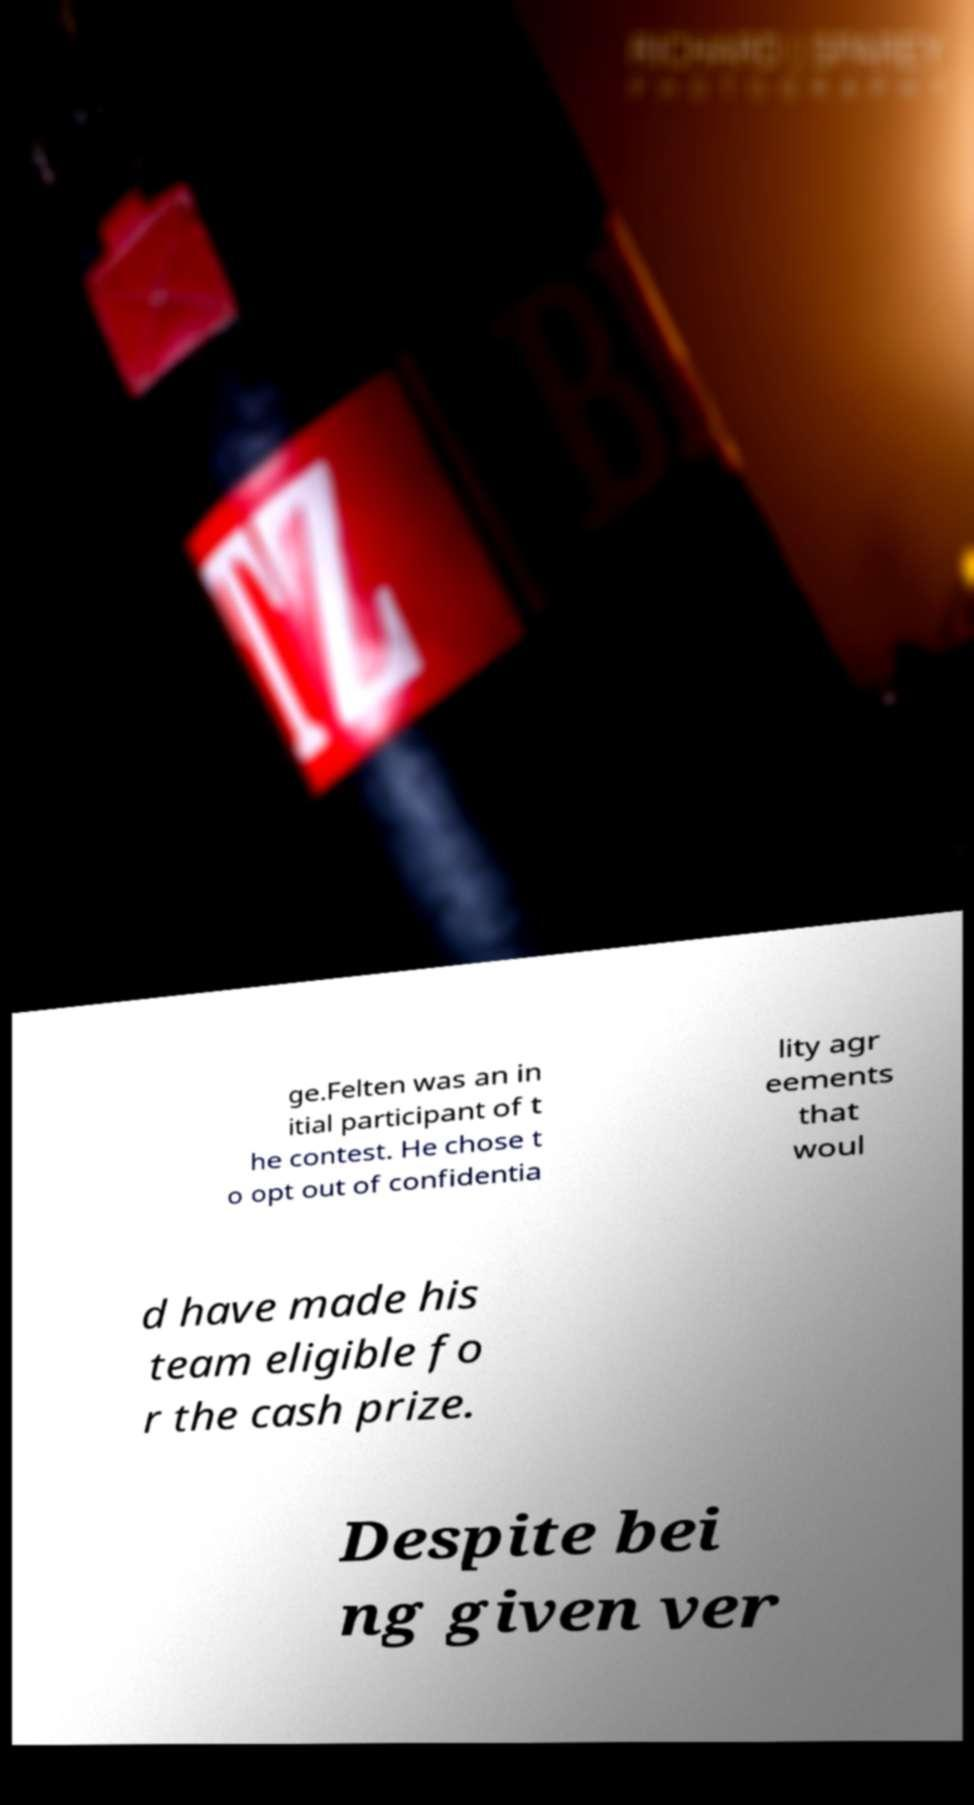I need the written content from this picture converted into text. Can you do that? ge.Felten was an in itial participant of t he contest. He chose t o opt out of confidentia lity agr eements that woul d have made his team eligible fo r the cash prize. Despite bei ng given ver 